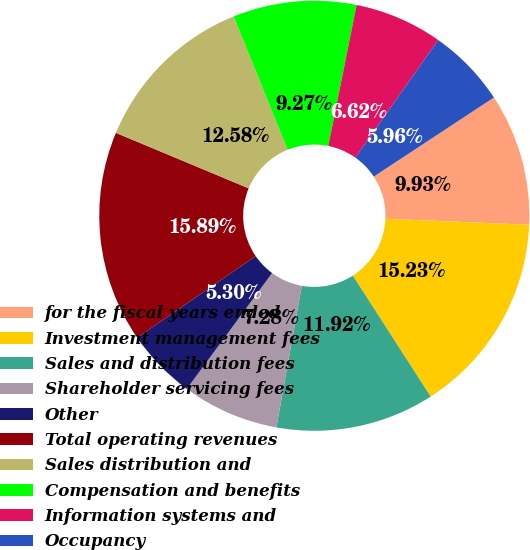Convert chart. <chart><loc_0><loc_0><loc_500><loc_500><pie_chart><fcel>for the fiscal years ended<fcel>Investment management fees<fcel>Sales and distribution fees<fcel>Shareholder servicing fees<fcel>Other<fcel>Total operating revenues<fcel>Sales distribution and<fcel>Compensation and benefits<fcel>Information systems and<fcel>Occupancy<nl><fcel>9.93%<fcel>15.23%<fcel>11.92%<fcel>7.28%<fcel>5.3%<fcel>15.89%<fcel>12.58%<fcel>9.27%<fcel>6.62%<fcel>5.96%<nl></chart> 